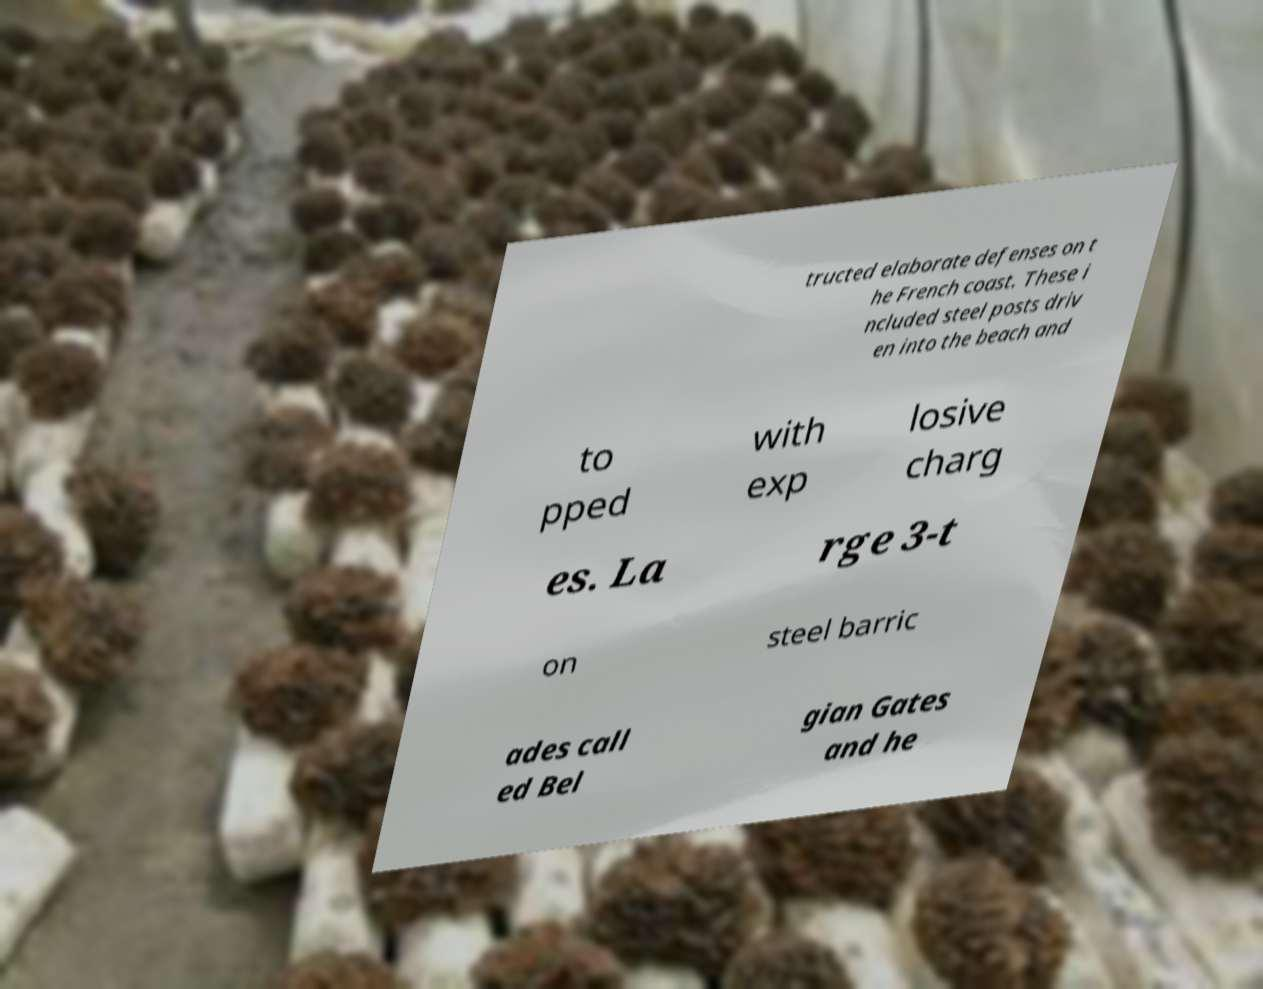Please identify and transcribe the text found in this image. tructed elaborate defenses on t he French coast. These i ncluded steel posts driv en into the beach and to pped with exp losive charg es. La rge 3-t on steel barric ades call ed Bel gian Gates and he 